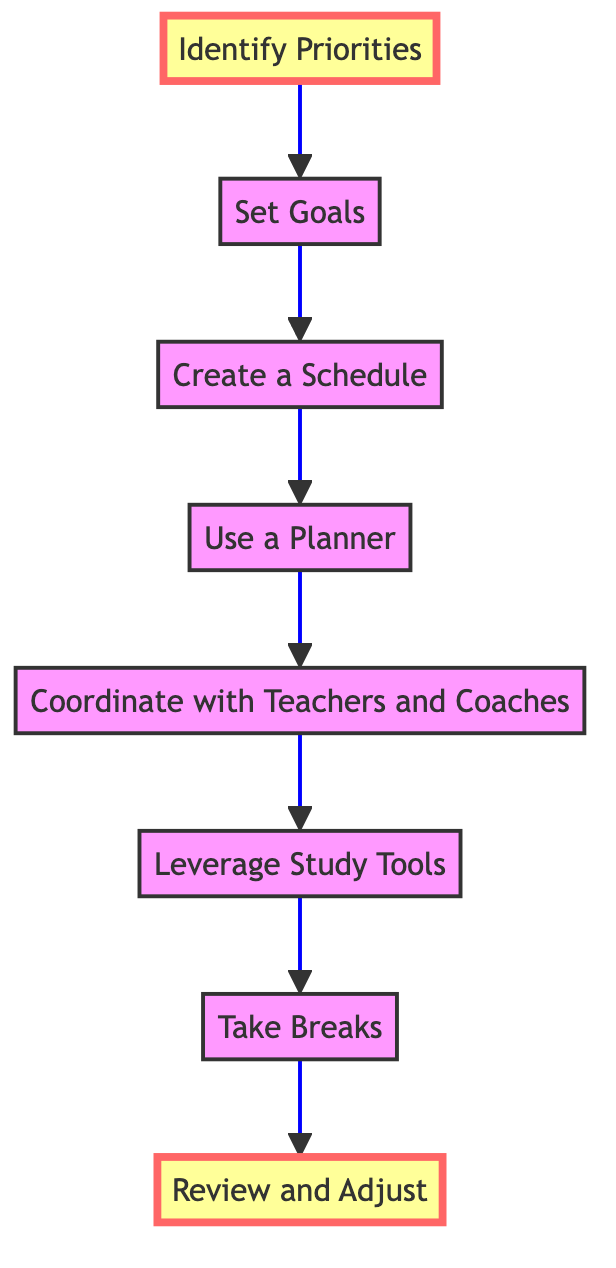What is the first step in the flow chart? The first step in the flow chart is "Identify Priorities," indicating that determining the importance of academics or sports is the starting point.
Answer: Identify Priorities How many nodes are there in the diagram? The diagram contains 8 nodes that represent different steps in balancing sports practices and academic commitments.
Answer: 8 What is the last step in the flow chart? The last step in the flow chart is "Review and Adjust," emphasizing the need for regular evaluation and modification of plans.
Answer: Review and Adjust Which node comes after "Use a Planner"? The node that follows "Use a Planner" is "Coordinate with Teachers and Coaches," linking planning with effective communication.
Answer: Coordinate with Teachers and Coaches What connections are associated with "Set Goals"? The connections associated with "Set Goals" lead to "Create a Schedule," representing the progression from setting objectives to organizing time.
Answer: Create a Schedule Which two steps are highlighted in the diagram? The highlighted steps are "Identify Priorities" and "Review and Adjust," indicating their importance in the process.
Answer: Identify Priorities and Review and Adjust What is the relationship between "Leverage Study Tools" and "Take Breaks"? The relationship is sequential; "Leverage Study Tools" must be completed before moving on to "Take Breaks," showcasing a flow of actions aimed at maintaining balance.
Answer: Leverage Study Tools to Take Breaks In what order do the first three steps occur? The first three steps occur in the following order: "Identify Priorities," followed by "Set Goals," and then "Create a Schedule," illustrating a logical progression toward balance.
Answer: Identify Priorities, Set Goals, Create a Schedule What action should be taken after "Take Breaks"? The action that should be taken after "Take Breaks" is "Review and Adjust," which emphasizes the importance of ongoing evaluation following rest.
Answer: Review and Adjust 